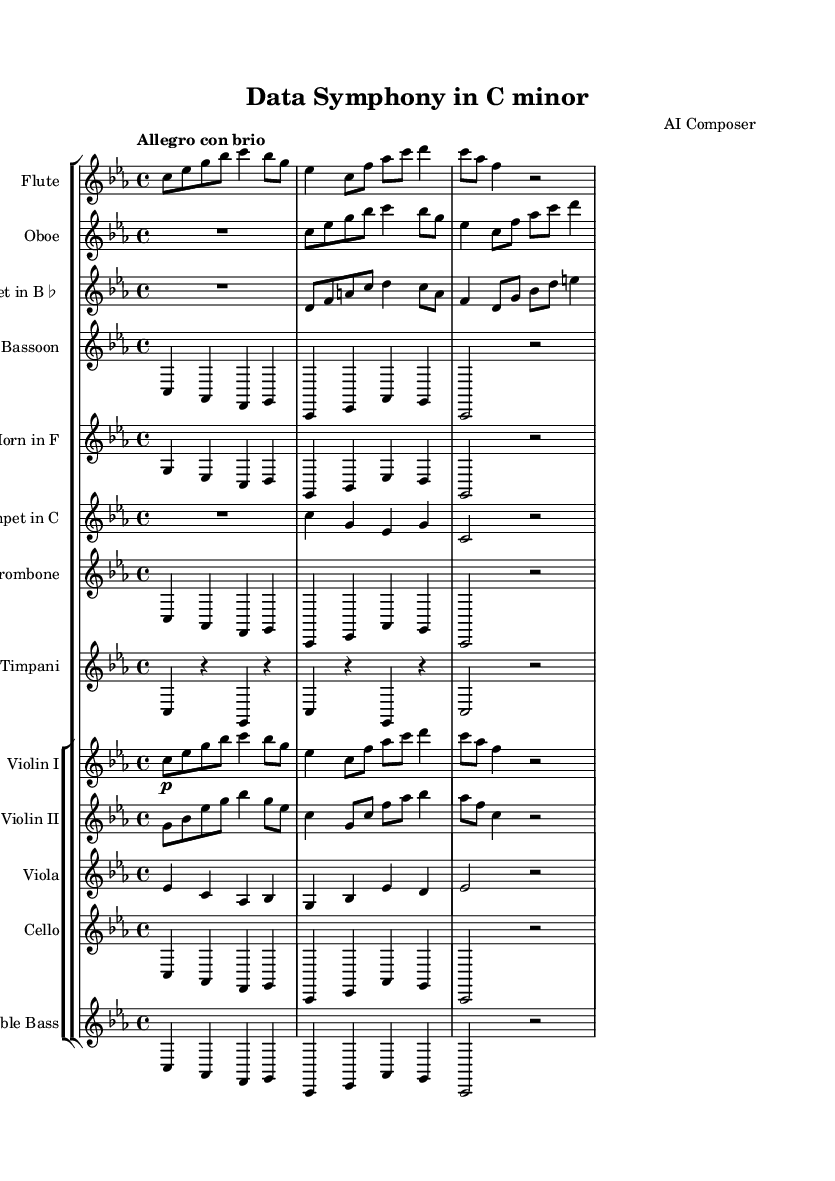What is the key signature of this symphony? The key signature is C minor, which is indicated by the three flat notes in the key signature area at the beginning of the score.
Answer: C minor What is the time signature of the music? The time signature of the music is indicated by the numbers at the beginning of the score; it shows that there are four beats per measure.
Answer: 4/4 What is the tempo marking for this piece? The tempo marking is provided at the beginning of the score, which shows how quickly the music should be played. The term "Allegro con brio" indicates a lively pace.
Answer: Allegro con brio How many instruments are represented in the score? By counting the staff groups and individual instruments listed in the score, we find that there are a total of 13 instrumental staves.
Answer: 13 Which woodwind instruments are featured in this symphony? Woodwind instruments can be identified by the specific staves labeled in the score; here, we see Flute, Oboe, Clarinet, and Bassoon listed.
Answer: Flute, Oboe, Clarinet, Bassoon What is the highest pitch instrument in this arrangement? The highest pitch instrument can be determined by looking at the clefs and ranges of each instrument; the Flute is the instrument that plays the highest range.
Answer: Flute What ensemble structure does this symphony follow? The ensemble structure is determined from the score layout, which includes sections for woodwinds, brass, percussion, and strings, indicating a full orchestral arrangement typical of Romantic symphonies.
Answer: Full orchestra 